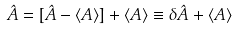Convert formula to latex. <formula><loc_0><loc_0><loc_500><loc_500>\hat { A } = [ \hat { A } - \langle { A } \rangle ] + \langle { A } \rangle \equiv \delta \hat { A } + \langle { A } \rangle</formula> 